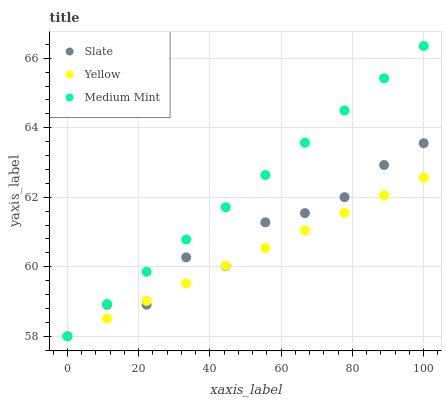Does Yellow have the minimum area under the curve?
Answer yes or no. Yes. Does Medium Mint have the maximum area under the curve?
Answer yes or no. Yes. Does Slate have the minimum area under the curve?
Answer yes or no. No. Does Slate have the maximum area under the curve?
Answer yes or no. No. Is Yellow the smoothest?
Answer yes or no. Yes. Is Slate the roughest?
Answer yes or no. Yes. Is Slate the smoothest?
Answer yes or no. No. Is Yellow the roughest?
Answer yes or no. No. Does Medium Mint have the lowest value?
Answer yes or no. Yes. Does Medium Mint have the highest value?
Answer yes or no. Yes. Does Slate have the highest value?
Answer yes or no. No. Does Yellow intersect Slate?
Answer yes or no. Yes. Is Yellow less than Slate?
Answer yes or no. No. Is Yellow greater than Slate?
Answer yes or no. No. 